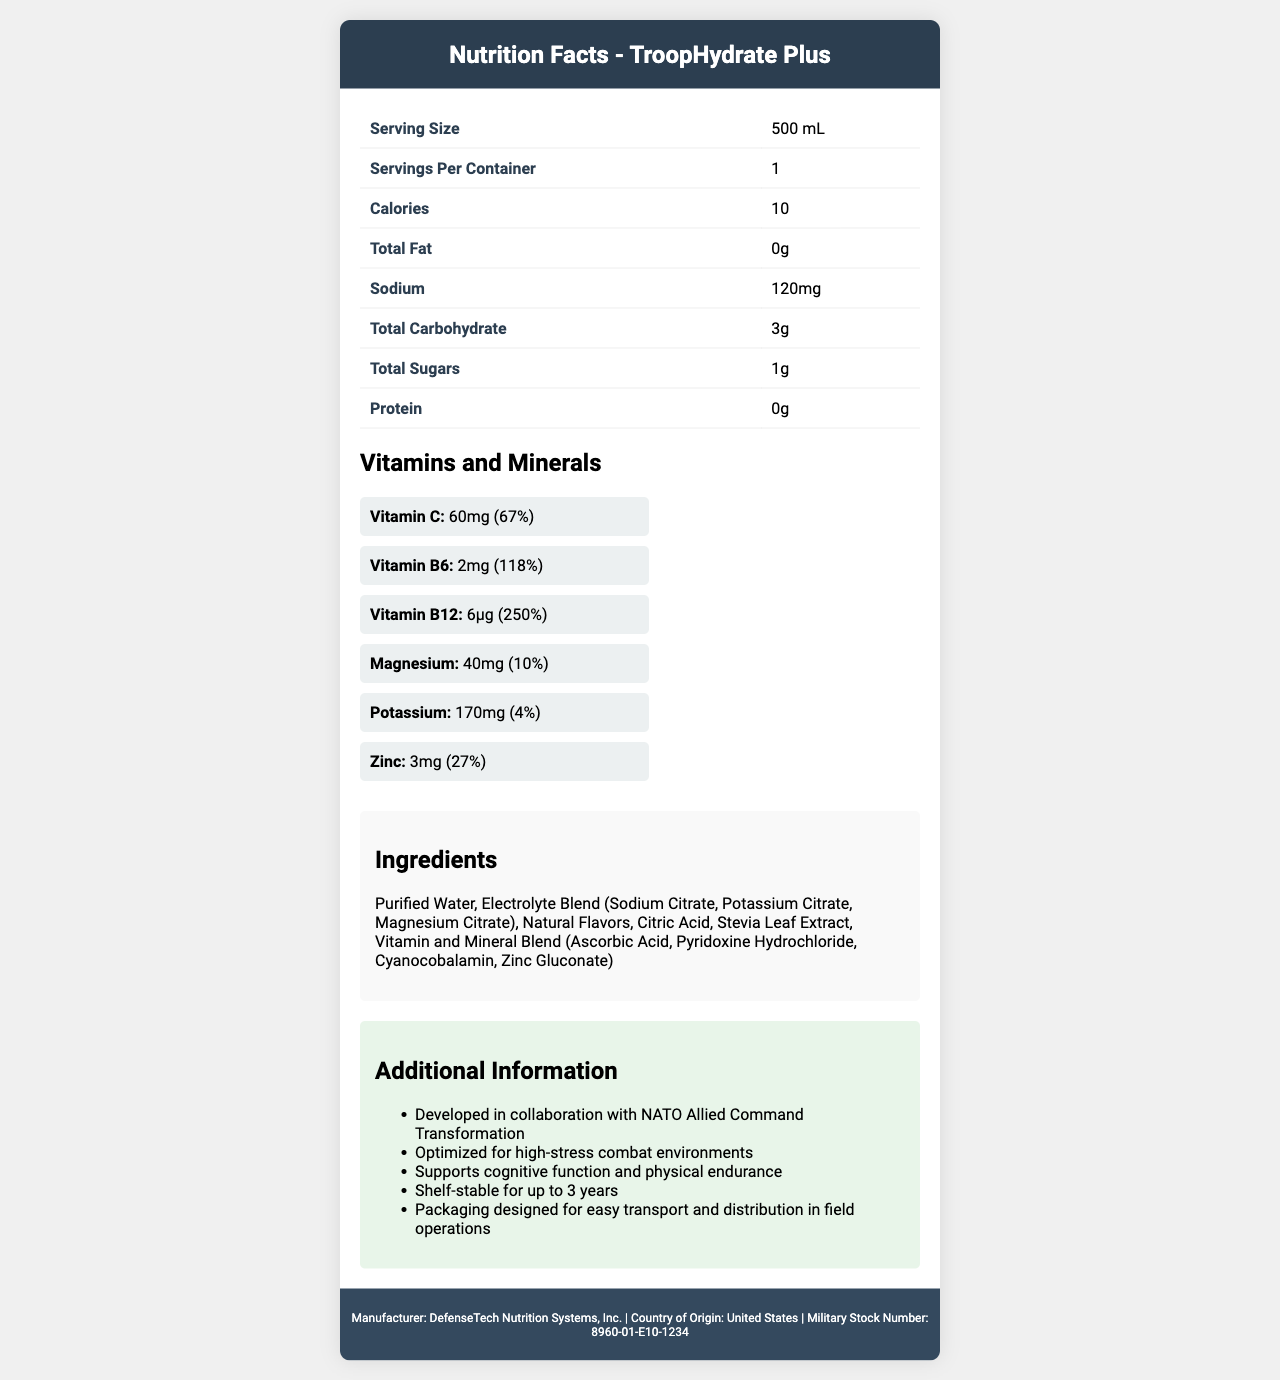who is the manufacturer of TroopHydrate Plus? The manufacturer information is provided in the footer of the document.
Answer: DefenseTech Nutrition Systems, Inc. what is the serving size of TroopHydrate Plus? The serving size is listed at the top of the nutrition facts section.
Answer: 500 mL how many servings are there per container? The number of servings per container is specified as "1" in the nutrition facts table.
Answer: 1 how much sodium is in one serving of TroopHydrate Plus? The sodium content is listed as 120mg in the nutrition facts table.
Answer: 120mg what percentage of the daily value for Vitamin B12 does one serving provide? The daily value percentage for Vitamin B12 is listed as 250% in the vitamins and minerals section.
Answer: 250% which vitamins are included in TroopHydrate Plus? A. Vitamin A, Vitamin C, Vitamin D B. Vitamin C, Vitamin B6, Vitamin B12 C. Vitamin B6, Vitamin B12, Vitamin D The vitamins present are Vitamin C, Vitamin B6, and Vitamin B12 as listed in the vitamins and minerals section.
Answer: B. Vitamin C, Vitamin B6, Vitamin B12 how many grams of total sugars are in TroopHydrate Plus? The total sugars content is specified as 1g in the nutrition facts table.
Answer: 1g what is one of the key functions supported by TroopHydrate Plus according to the additional information? A. Cognitive function B. Weight loss C. Muscle building The additional information section mentions that the product supports cognitive function.
Answer: A. Cognitive function does TroopHydrate Plus contain any fat? The total fat content is listed as 0g in the nutrition facts table.
Answer: No is this product shelf-stable for a long period? The additional information states that the product is shelf-stable for up to 3 years.
Answer: Yes is TroopHydrate Plus optimized for low-stress environments? The additional information section mentions that it is optimized for high-stress combat environments.
Answer: No how is TroopHydrate Plus designed in terms of transport and distribution? The additional information section notes that the packaging is designed for easy transport and distribution in field operations.
Answer: Easy transport and distribution where is TroopHydrate Plus manufactured? The country of origin is mentioned as the United States in the footer of the document.
Answer: United States describe the main idea of the document The document includes sections on nutritional content, ingredients, vitamins and minerals, and additional capabilities of the product, all aimed at providing a comprehensive overview of TroopHydrate Plus.
Answer: The document provides detailed nutritional facts and additional information about TroopHydrate Plus, a fortified water supply for troops, including its serving size, ingredients, vitamins, and capabilities designed to support military personnel in challenging environments. what is the military stock number for TroopHydrate Plus? The military stock number is listed in the footer of the document.
Answer: 8960-01-E10-1234 how much protein is in a serving of TroopHydrate Plus? The protein content is listed as 0g in the nutrition facts table.
Answer: 0g what is the primary sweetener used in TroopHydrate Plus? The ingredients list includes Stevia Leaf Extract as a key ingredient.
Answer: Stevia Leaf Extract how are the vitamins and minerals presented in the document? The vitamins and minerals section presents each item, their amounts, and their daily values in a visually clear format.
Answer: Displayed as individual items with their amounts and daily values what is the primary benefit of the electrolyte blend in TroopHydrate Plus? The document lists the electrolyte blend ingredients but does not specify their primary benefit directly.
Answer: Not enough information 